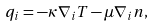<formula> <loc_0><loc_0><loc_500><loc_500>q _ { i } = - \kappa \nabla _ { i } T - \mu \nabla _ { i } n ,</formula> 